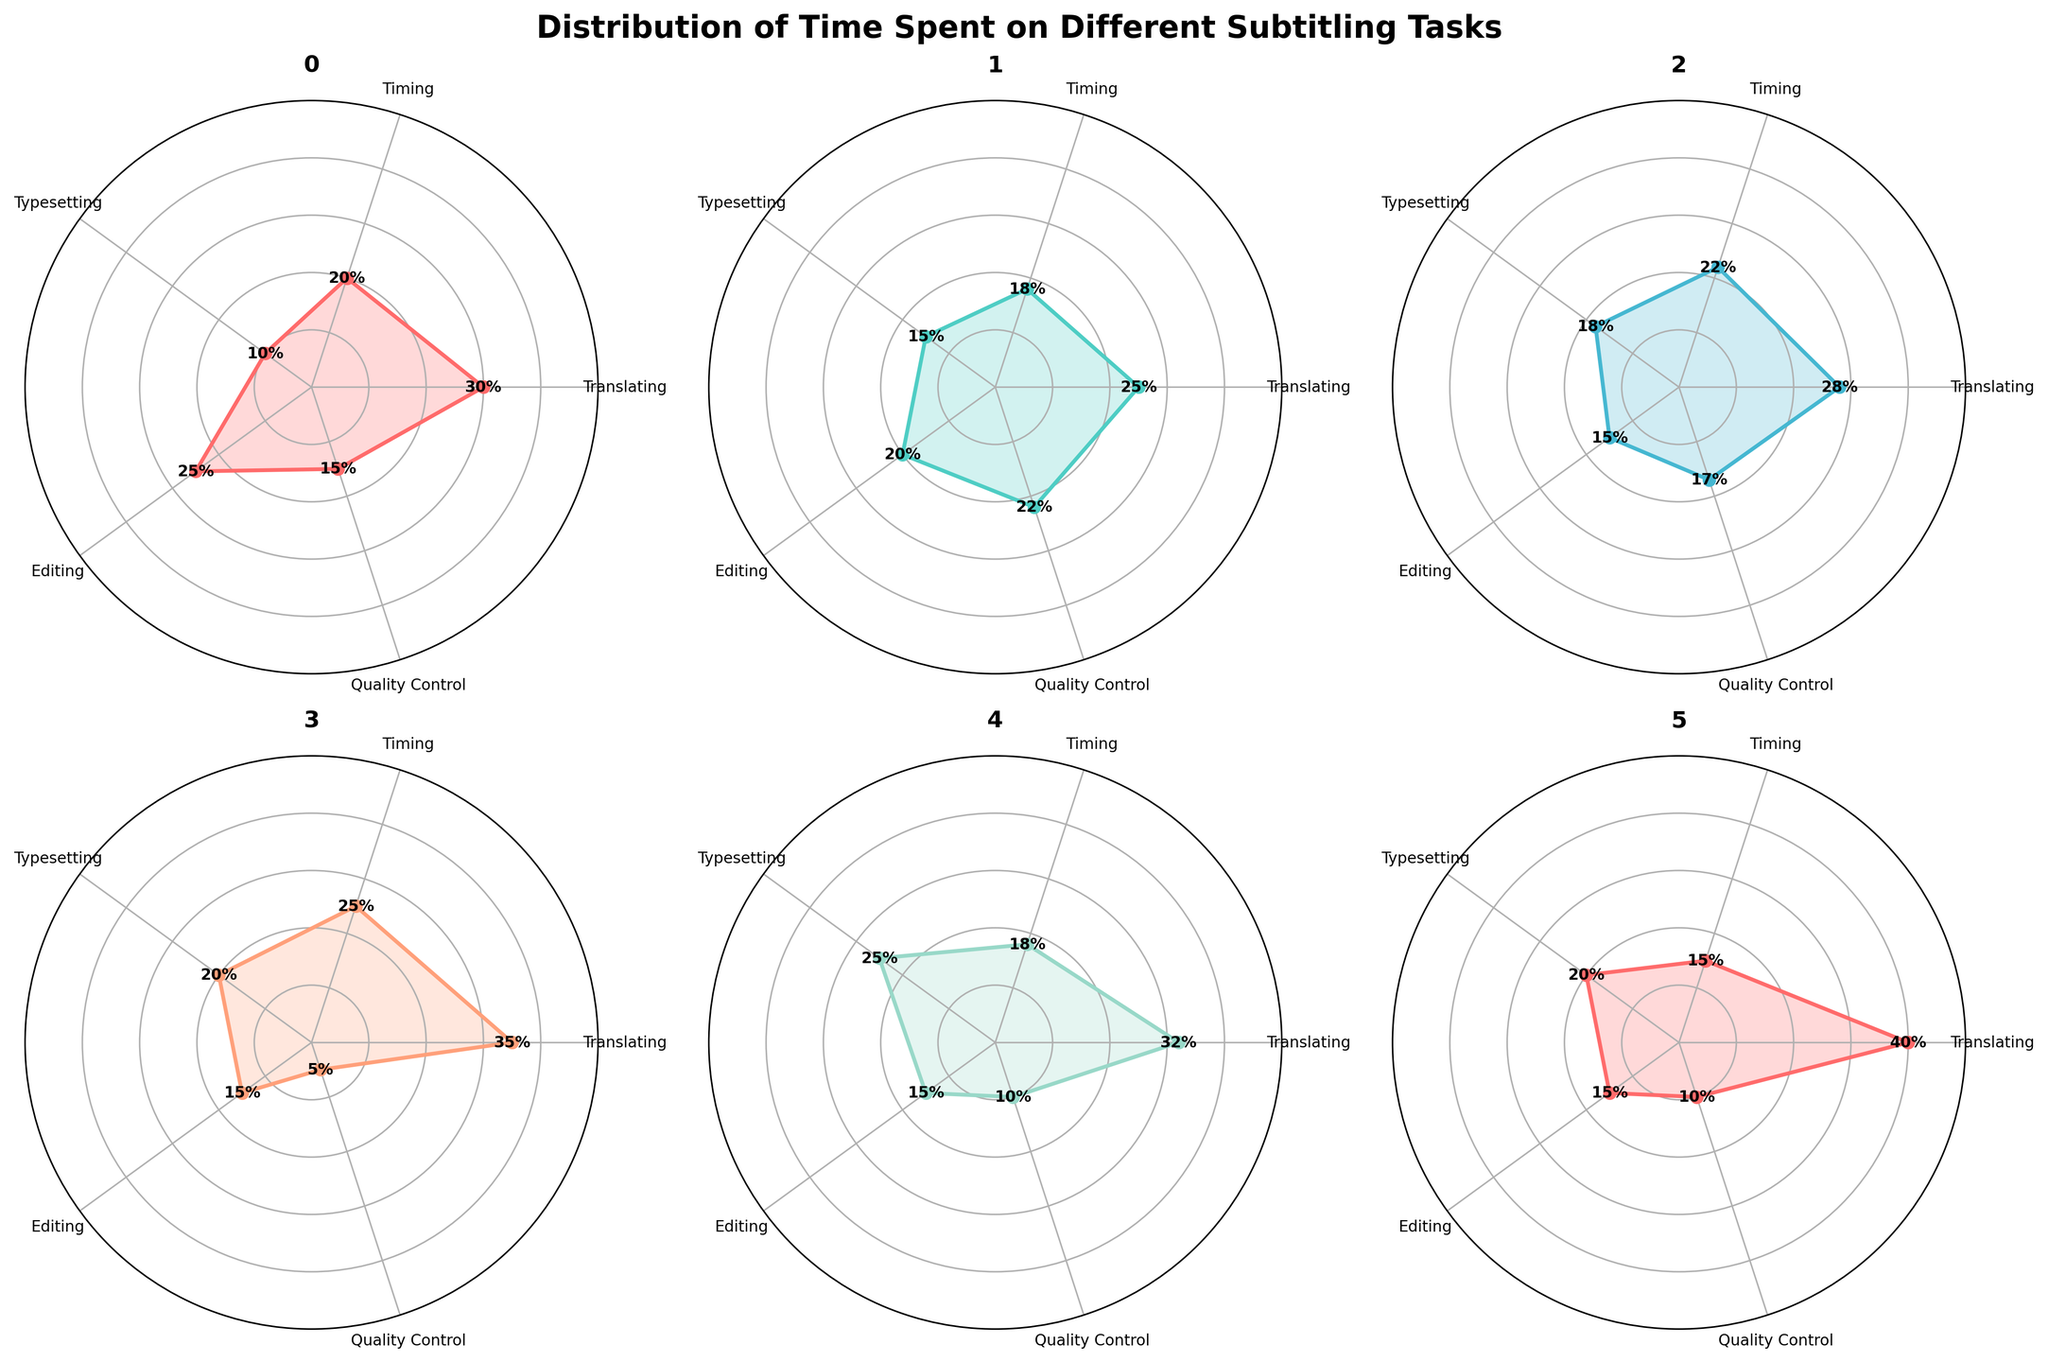What is the title of the figure? The title of a figure is usually positioned at the top and is often in a larger or bolder font to stand out. From the code, we know that the title is set for the entire visualization.
Answer: Distribution of Time Spent on Different Subtitling Tasks Which task takes the most time in Episode 1? Look at the Polar Chart subplot for Episode 1 and identify which task has the longest segment. Translating has a value of 30%, which is the highest.
Answer: Translating Between Episode 3 and the Movie, which one spent more time on Typesetting? Compare the value of Typesetting for Episode 3 and the Movie. Episode 3 has 18% and the Movie has 20%; the latter is higher.
Answer: Movie What is the smallest time percentage recorded for the Movie and which task does it correlate to? Find the smallest segment in the Movie's chart. Quality Control is the smallest with 5%.
Answer: Quality Control Calculate the average time spent on Editing across all the subplots. Sum the percentage values for Editing for all the episodes and divide by the number of episodes:
(25 + 20 + 15 + 15 + 15 + 15) / 6 = 105 / 6 = 17.5
Answer: 17.5 How does the time spent on Timing for Episode 2 compare to Special 1? Look at the Timing values for Episode 2 and Special 1. Episode 2 has 18% and Special 1 has 15%; Episode 2's value is higher.
Answer: Episode 2 has more Which episode or special has the most balanced distribution of time across all tasks? A balanced distribution would show segments of similar lengths. From visual inspection, Episode 2 and Episode 3 appear to have the most similar lengths for each task segment compared to others.
Answer: Episode 2 or Episode 3 What is the most common minimum percentage value for any task across all subplots? Identify the tasks with the smallest percentage for each subplot. Multiple episodes have a minimum value of 15%, making it the most common.
Answer: 15 Summarize the overall trend in time allocation for Quality Control across all subplots. Find the Quality Control values for all the subplots: 15, 22, 17, 5, 10, 10. The values usually range around 10-22% with one exception (5% for the Movie), indicating relatively lower but consistent allocation.
Answer: Generally low, except for Episode 2 at 22% Out of all the tasks, which one appears to have the highest frequency of being the time-intensive task? Identify the task which has the highest value in the most number of subplots. Translating appears most frequently as the maximum value task (in 4 subplots).
Answer: Translating 